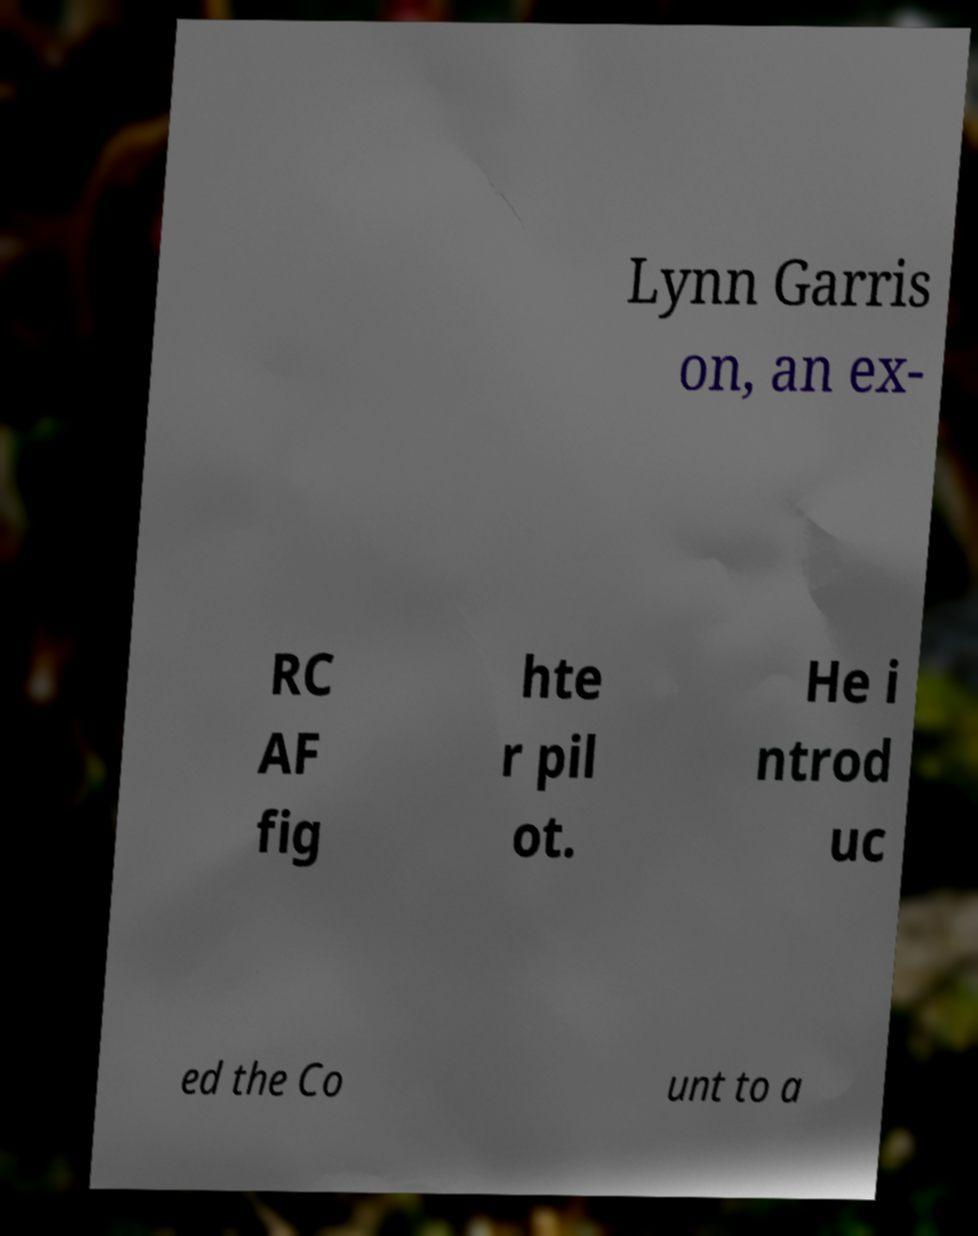Could you assist in decoding the text presented in this image and type it out clearly? Lynn Garris on, an ex- RC AF fig hte r pil ot. He i ntrod uc ed the Co unt to a 